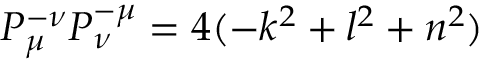Convert formula to latex. <formula><loc_0><loc_0><loc_500><loc_500>P _ { \mu } ^ { - \nu } P _ { \nu } ^ { - \mu } = 4 ( - k ^ { 2 } + l ^ { 2 } + n ^ { 2 } )</formula> 